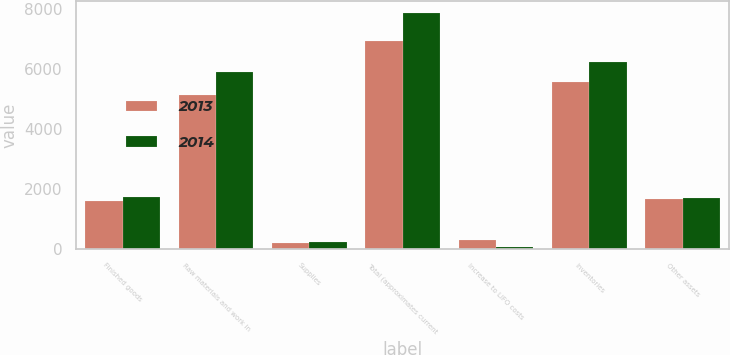Convert chart to OTSL. <chart><loc_0><loc_0><loc_500><loc_500><stacked_bar_chart><ecel><fcel>Finished goods<fcel>Raw materials and work in<fcel>Supplies<fcel>Total (approximates current<fcel>Increase to LIFO costs<fcel>Inventories<fcel>Other assets<nl><fcel>2013<fcel>1588<fcel>5141<fcel>197<fcel>6926<fcel>309<fcel>5571<fcel>1664<nl><fcel>2014<fcel>1738<fcel>5894<fcel>225<fcel>7857<fcel>73<fcel>6226<fcel>1704<nl></chart> 